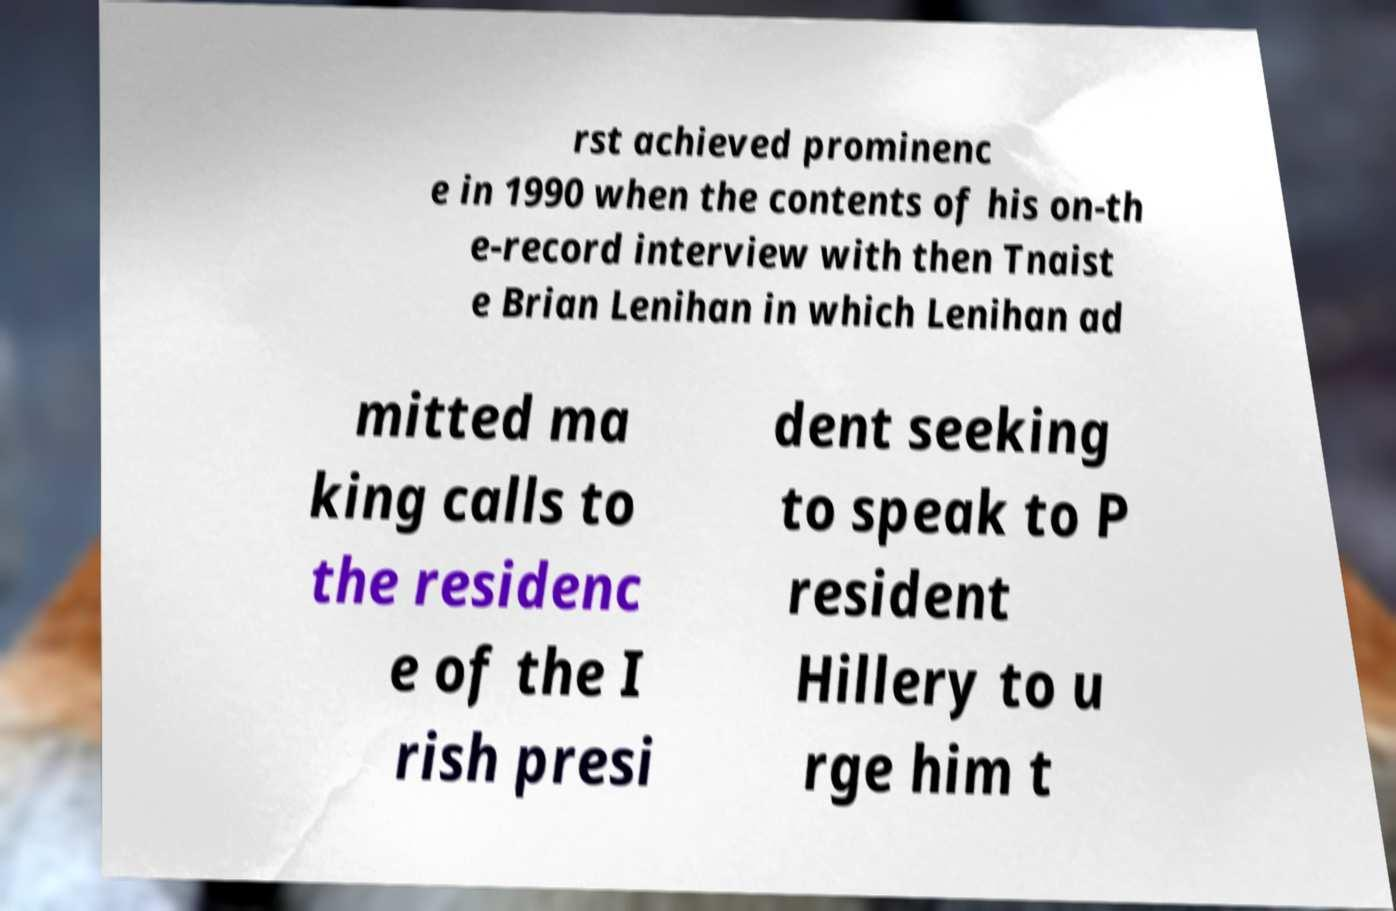Can you read and provide the text displayed in the image?This photo seems to have some interesting text. Can you extract and type it out for me? rst achieved prominenc e in 1990 when the contents of his on-th e-record interview with then Tnaist e Brian Lenihan in which Lenihan ad mitted ma king calls to the residenc e of the I rish presi dent seeking to speak to P resident Hillery to u rge him t 